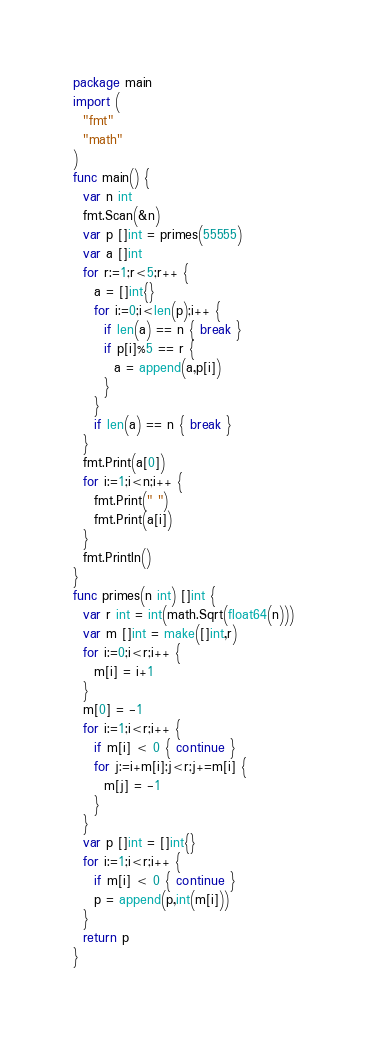Convert code to text. <code><loc_0><loc_0><loc_500><loc_500><_Go_>package main
import (
  "fmt"
  "math"
)
func main() {
  var n int
  fmt.Scan(&n)
  var p []int = primes(55555)
  var a []int
  for r:=1;r<5;r++ {
    a = []int{}
    for i:=0;i<len(p);i++ {
      if len(a) == n { break }
      if p[i]%5 == r {
        a = append(a,p[i])
      }
    }
    if len(a) == n { break }
  }
  fmt.Print(a[0])
  for i:=1;i<n;i++ {
    fmt.Print(" ")
    fmt.Print(a[i])
  }
  fmt.Println()
}
func primes(n int) []int {
  var r int = int(math.Sqrt(float64(n)))
  var m []int = make([]int,r)
  for i:=0;i<r;i++ {
    m[i] = i+1
  }
  m[0] = -1
  for i:=1;i<r;i++ {
    if m[i] < 0 { continue }
    for j:=i+m[i];j<r;j+=m[i] {
      m[j] = -1
    }
  }
  var p []int = []int{}
  for i:=1;i<r;i++ {
    if m[i] < 0 { continue }
    p = append(p,int(m[i]))
  }
  return p
}</code> 